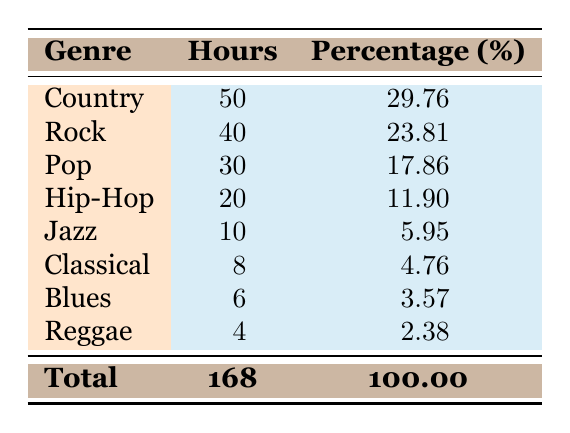What genre has the highest allocation of hours on air? The genre with the highest allocation of hours is "Country," which has 50 hours allocated. This is the largest number listed in the "Hours" column.
Answer: Country What percentage of the total on-air time is allocated to Pop music? The percentage allocated to Pop music is 17.86%, which can be directly found in the "Percentage" column next to the Pop genre.
Answer: 17.86% How many hours are allocated to genres other than Rock and Country? To find this, sum the hours for all genres except Rock (40 hours) and Country (50 hours): 30 (Pop) + 20 (Hip-Hop) + 10 (Jazz) + 8 (Classical) + 6 (Blues) + 4 (Reggae) = 78 hours.
Answer: 78 Is the allocation of hours for Jazz greater than that of Reggae? Yes, Jazz has 10 hours allocated, which is greater than the 4 hours allocated to Reggae. This can be verified by comparing the values in their respective rows.
Answer: Yes What is the total number of hours allocated to the top three genres? The top three genres are Country (50 hours), Rock (40 hours), and Pop (30 hours). Adding these gives: 50 + 40 + 30 = 120 hours.
Answer: 120 Which genre has the lowest percentage allocation, and what is that percentage? The genre with the lowest percentage allocation is Reggae, with a percentage of 2.38%. This can be found in the last row.
Answer: Reggae, 2.38% If we combine the hours for Blues and Classical, how many hours are allocated in total? The hours allocated to Blues are 6 and to Classical are 8. Adding these gives: 6 + 8 = 14 hours.
Answer: 14 What percentage of the total on-air time does Hip-Hop represent? The percentage of total on-air time that Hip-Hop represents is 11.90%, which is found in the corresponding row for Hip-Hop in the "Percentage" column.
Answer: 11.90% 